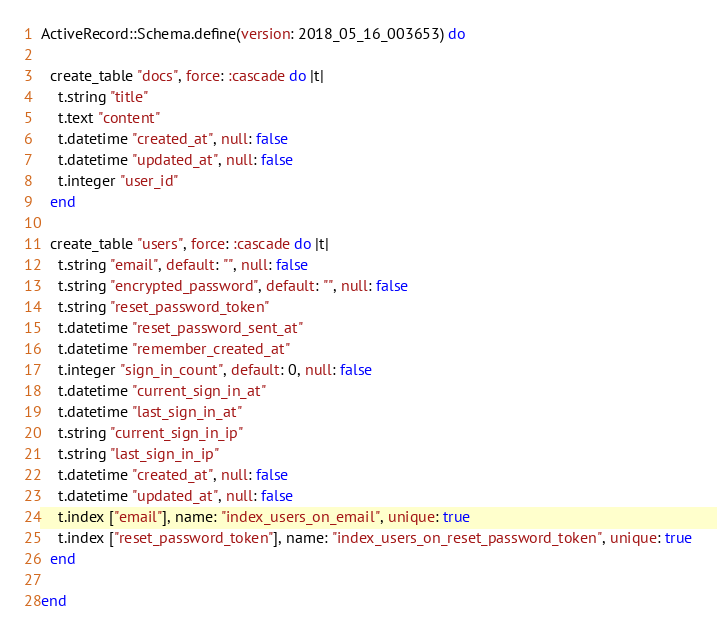<code> <loc_0><loc_0><loc_500><loc_500><_Ruby_>ActiveRecord::Schema.define(version: 2018_05_16_003653) do

  create_table "docs", force: :cascade do |t|
    t.string "title"
    t.text "content"
    t.datetime "created_at", null: false
    t.datetime "updated_at", null: false
    t.integer "user_id"
  end

  create_table "users", force: :cascade do |t|
    t.string "email", default: "", null: false
    t.string "encrypted_password", default: "", null: false
    t.string "reset_password_token"
    t.datetime "reset_password_sent_at"
    t.datetime "remember_created_at"
    t.integer "sign_in_count", default: 0, null: false
    t.datetime "current_sign_in_at"
    t.datetime "last_sign_in_at"
    t.string "current_sign_in_ip"
    t.string "last_sign_in_ip"
    t.datetime "created_at", null: false
    t.datetime "updated_at", null: false
    t.index ["email"], name: "index_users_on_email", unique: true
    t.index ["reset_password_token"], name: "index_users_on_reset_password_token", unique: true
  end

end
</code> 